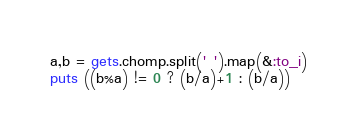Convert code to text. <code><loc_0><loc_0><loc_500><loc_500><_Ruby_>a,b = gets.chomp.split(' ').map(&:to_i)
puts ((b%a) != 0 ? (b/a)+1 : (b/a))</code> 